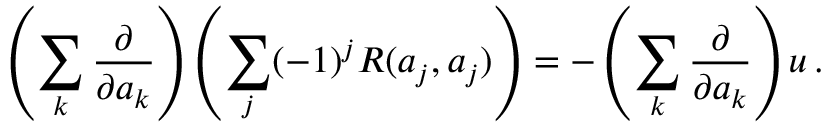<formula> <loc_0><loc_0><loc_500><loc_500>\left ( \sum _ { k } { \frac { \partial } { \partial a _ { k } } } \right ) \left ( \sum _ { j } ( - 1 ) ^ { j } R ( a _ { j } , a _ { j } ) \right ) = - \left ( \sum _ { k } { \frac { \partial } { \partial a _ { k } } } \right ) u \, .</formula> 